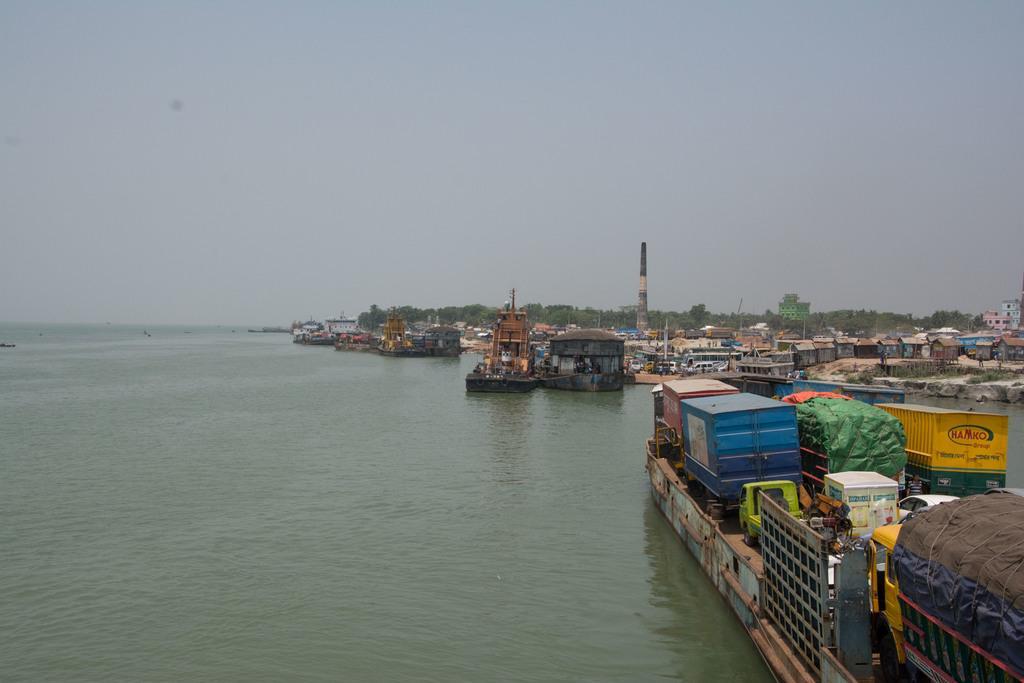Describe this image in one or two sentences. This image is taken outdoors. At the top of the image there is a sky. On the left side of the image there is a river with water. On the right side of the image there are many boats with a huge luggage in them. In the background there are a few trees and buildings and there are a few houses. 